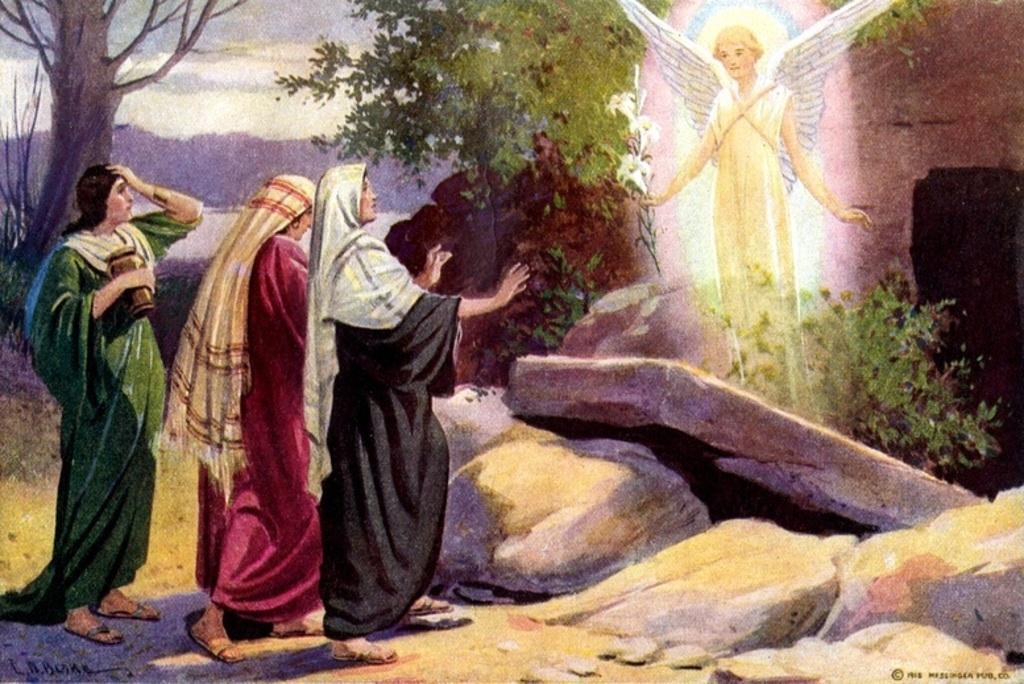Could you give a brief overview of what you see in this image? In the picture I can see a painting of people, rocks, trees, plants and some other things. In the background I can see the sky. 